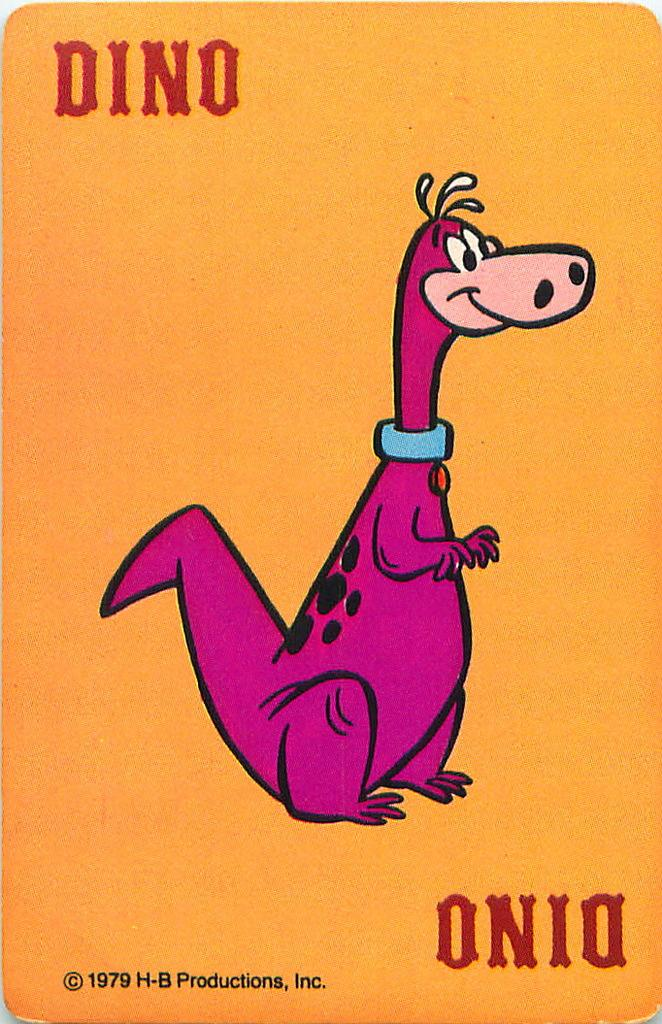What type of visual is shown in the image? The image is a poster. What is the main subject of the poster? There is an animal depicted on the poster. Are there any words or phrases on the poster? Yes, there is text present on the poster. What time of day is depicted in the image? The image does not depict a specific time of day, as it is a poster with an animal and text. Can you describe the waves in the image? There are no waves present in the image; it is a poster with an animal and text. 